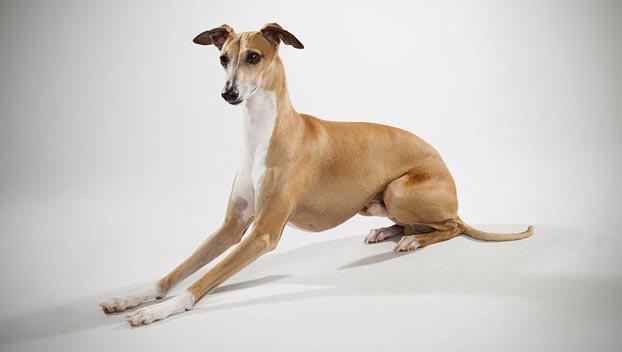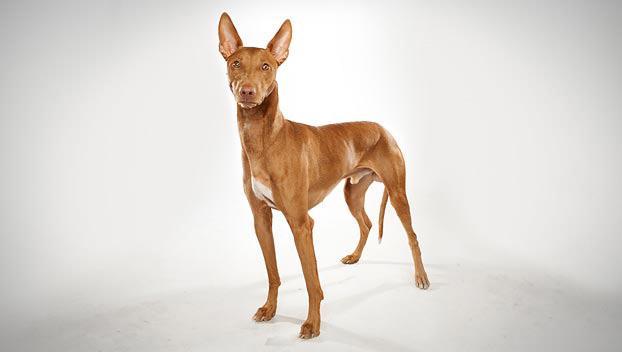The first image is the image on the left, the second image is the image on the right. Evaluate the accuracy of this statement regarding the images: "In one of the images, there is a brown and white dog standing in grass". Is it true? Answer yes or no. No. 